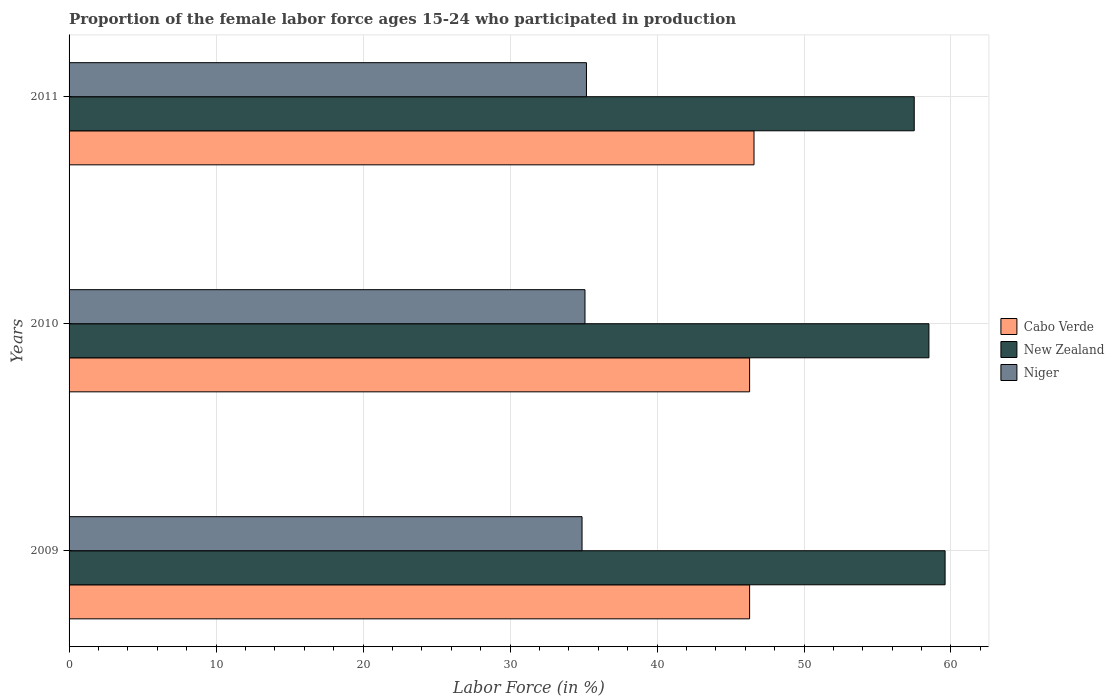Are the number of bars per tick equal to the number of legend labels?
Provide a succinct answer. Yes. Are the number of bars on each tick of the Y-axis equal?
Ensure brevity in your answer.  Yes. How many bars are there on the 3rd tick from the top?
Offer a very short reply. 3. How many bars are there on the 2nd tick from the bottom?
Offer a very short reply. 3. What is the label of the 1st group of bars from the top?
Make the answer very short. 2011. What is the proportion of the female labor force who participated in production in Cabo Verde in 2011?
Ensure brevity in your answer.  46.6. Across all years, what is the maximum proportion of the female labor force who participated in production in Niger?
Your response must be concise. 35.2. Across all years, what is the minimum proportion of the female labor force who participated in production in New Zealand?
Offer a terse response. 57.5. In which year was the proportion of the female labor force who participated in production in Cabo Verde maximum?
Offer a very short reply. 2011. What is the total proportion of the female labor force who participated in production in Cabo Verde in the graph?
Your response must be concise. 139.2. What is the difference between the proportion of the female labor force who participated in production in New Zealand in 2009 and that in 2011?
Give a very brief answer. 2.1. What is the difference between the proportion of the female labor force who participated in production in Cabo Verde in 2009 and the proportion of the female labor force who participated in production in Niger in 2011?
Provide a short and direct response. 11.1. What is the average proportion of the female labor force who participated in production in Niger per year?
Your response must be concise. 35.07. In the year 2009, what is the difference between the proportion of the female labor force who participated in production in Cabo Verde and proportion of the female labor force who participated in production in Niger?
Your answer should be compact. 11.4. What is the ratio of the proportion of the female labor force who participated in production in New Zealand in 2009 to that in 2010?
Provide a succinct answer. 1.02. Is the proportion of the female labor force who participated in production in Niger in 2009 less than that in 2011?
Keep it short and to the point. Yes. What is the difference between the highest and the second highest proportion of the female labor force who participated in production in Cabo Verde?
Provide a short and direct response. 0.3. What is the difference between the highest and the lowest proportion of the female labor force who participated in production in Niger?
Offer a terse response. 0.3. In how many years, is the proportion of the female labor force who participated in production in Niger greater than the average proportion of the female labor force who participated in production in Niger taken over all years?
Keep it short and to the point. 2. Is the sum of the proportion of the female labor force who participated in production in Niger in 2009 and 2011 greater than the maximum proportion of the female labor force who participated in production in Cabo Verde across all years?
Give a very brief answer. Yes. What does the 3rd bar from the top in 2010 represents?
Make the answer very short. Cabo Verde. What does the 2nd bar from the bottom in 2011 represents?
Ensure brevity in your answer.  New Zealand. How many bars are there?
Provide a short and direct response. 9. Are all the bars in the graph horizontal?
Provide a succinct answer. Yes. How many years are there in the graph?
Make the answer very short. 3. Does the graph contain any zero values?
Offer a terse response. No. Does the graph contain grids?
Provide a short and direct response. Yes. Where does the legend appear in the graph?
Your answer should be very brief. Center right. What is the title of the graph?
Your response must be concise. Proportion of the female labor force ages 15-24 who participated in production. What is the label or title of the X-axis?
Give a very brief answer. Labor Force (in %). What is the Labor Force (in %) in Cabo Verde in 2009?
Your answer should be very brief. 46.3. What is the Labor Force (in %) of New Zealand in 2009?
Your response must be concise. 59.6. What is the Labor Force (in %) in Niger in 2009?
Keep it short and to the point. 34.9. What is the Labor Force (in %) of Cabo Verde in 2010?
Give a very brief answer. 46.3. What is the Labor Force (in %) in New Zealand in 2010?
Your answer should be very brief. 58.5. What is the Labor Force (in %) of Niger in 2010?
Make the answer very short. 35.1. What is the Labor Force (in %) of Cabo Verde in 2011?
Provide a succinct answer. 46.6. What is the Labor Force (in %) of New Zealand in 2011?
Make the answer very short. 57.5. What is the Labor Force (in %) of Niger in 2011?
Your answer should be compact. 35.2. Across all years, what is the maximum Labor Force (in %) in Cabo Verde?
Provide a short and direct response. 46.6. Across all years, what is the maximum Labor Force (in %) in New Zealand?
Your answer should be compact. 59.6. Across all years, what is the maximum Labor Force (in %) in Niger?
Offer a very short reply. 35.2. Across all years, what is the minimum Labor Force (in %) of Cabo Verde?
Offer a very short reply. 46.3. Across all years, what is the minimum Labor Force (in %) of New Zealand?
Offer a very short reply. 57.5. Across all years, what is the minimum Labor Force (in %) in Niger?
Your answer should be compact. 34.9. What is the total Labor Force (in %) of Cabo Verde in the graph?
Offer a very short reply. 139.2. What is the total Labor Force (in %) in New Zealand in the graph?
Your response must be concise. 175.6. What is the total Labor Force (in %) in Niger in the graph?
Provide a succinct answer. 105.2. What is the difference between the Labor Force (in %) of Niger in 2009 and that in 2010?
Make the answer very short. -0.2. What is the difference between the Labor Force (in %) of Niger in 2009 and that in 2011?
Make the answer very short. -0.3. What is the difference between the Labor Force (in %) of New Zealand in 2010 and that in 2011?
Your answer should be compact. 1. What is the difference between the Labor Force (in %) of Niger in 2010 and that in 2011?
Give a very brief answer. -0.1. What is the difference between the Labor Force (in %) of Cabo Verde in 2009 and the Labor Force (in %) of New Zealand in 2010?
Ensure brevity in your answer.  -12.2. What is the difference between the Labor Force (in %) of Cabo Verde in 2009 and the Labor Force (in %) of New Zealand in 2011?
Offer a very short reply. -11.2. What is the difference between the Labor Force (in %) in New Zealand in 2009 and the Labor Force (in %) in Niger in 2011?
Keep it short and to the point. 24.4. What is the difference between the Labor Force (in %) of Cabo Verde in 2010 and the Labor Force (in %) of New Zealand in 2011?
Offer a very short reply. -11.2. What is the difference between the Labor Force (in %) in Cabo Verde in 2010 and the Labor Force (in %) in Niger in 2011?
Ensure brevity in your answer.  11.1. What is the difference between the Labor Force (in %) of New Zealand in 2010 and the Labor Force (in %) of Niger in 2011?
Make the answer very short. 23.3. What is the average Labor Force (in %) of Cabo Verde per year?
Offer a terse response. 46.4. What is the average Labor Force (in %) in New Zealand per year?
Provide a short and direct response. 58.53. What is the average Labor Force (in %) of Niger per year?
Offer a terse response. 35.07. In the year 2009, what is the difference between the Labor Force (in %) of Cabo Verde and Labor Force (in %) of New Zealand?
Your answer should be compact. -13.3. In the year 2009, what is the difference between the Labor Force (in %) of New Zealand and Labor Force (in %) of Niger?
Give a very brief answer. 24.7. In the year 2010, what is the difference between the Labor Force (in %) in Cabo Verde and Labor Force (in %) in Niger?
Ensure brevity in your answer.  11.2. In the year 2010, what is the difference between the Labor Force (in %) of New Zealand and Labor Force (in %) of Niger?
Give a very brief answer. 23.4. In the year 2011, what is the difference between the Labor Force (in %) of Cabo Verde and Labor Force (in %) of New Zealand?
Ensure brevity in your answer.  -10.9. In the year 2011, what is the difference between the Labor Force (in %) of New Zealand and Labor Force (in %) of Niger?
Make the answer very short. 22.3. What is the ratio of the Labor Force (in %) in New Zealand in 2009 to that in 2010?
Your answer should be compact. 1.02. What is the ratio of the Labor Force (in %) in Cabo Verde in 2009 to that in 2011?
Keep it short and to the point. 0.99. What is the ratio of the Labor Force (in %) in New Zealand in 2009 to that in 2011?
Your response must be concise. 1.04. What is the ratio of the Labor Force (in %) in New Zealand in 2010 to that in 2011?
Provide a short and direct response. 1.02. What is the difference between the highest and the second highest Labor Force (in %) in Niger?
Your answer should be very brief. 0.1. What is the difference between the highest and the lowest Labor Force (in %) of Cabo Verde?
Keep it short and to the point. 0.3. 